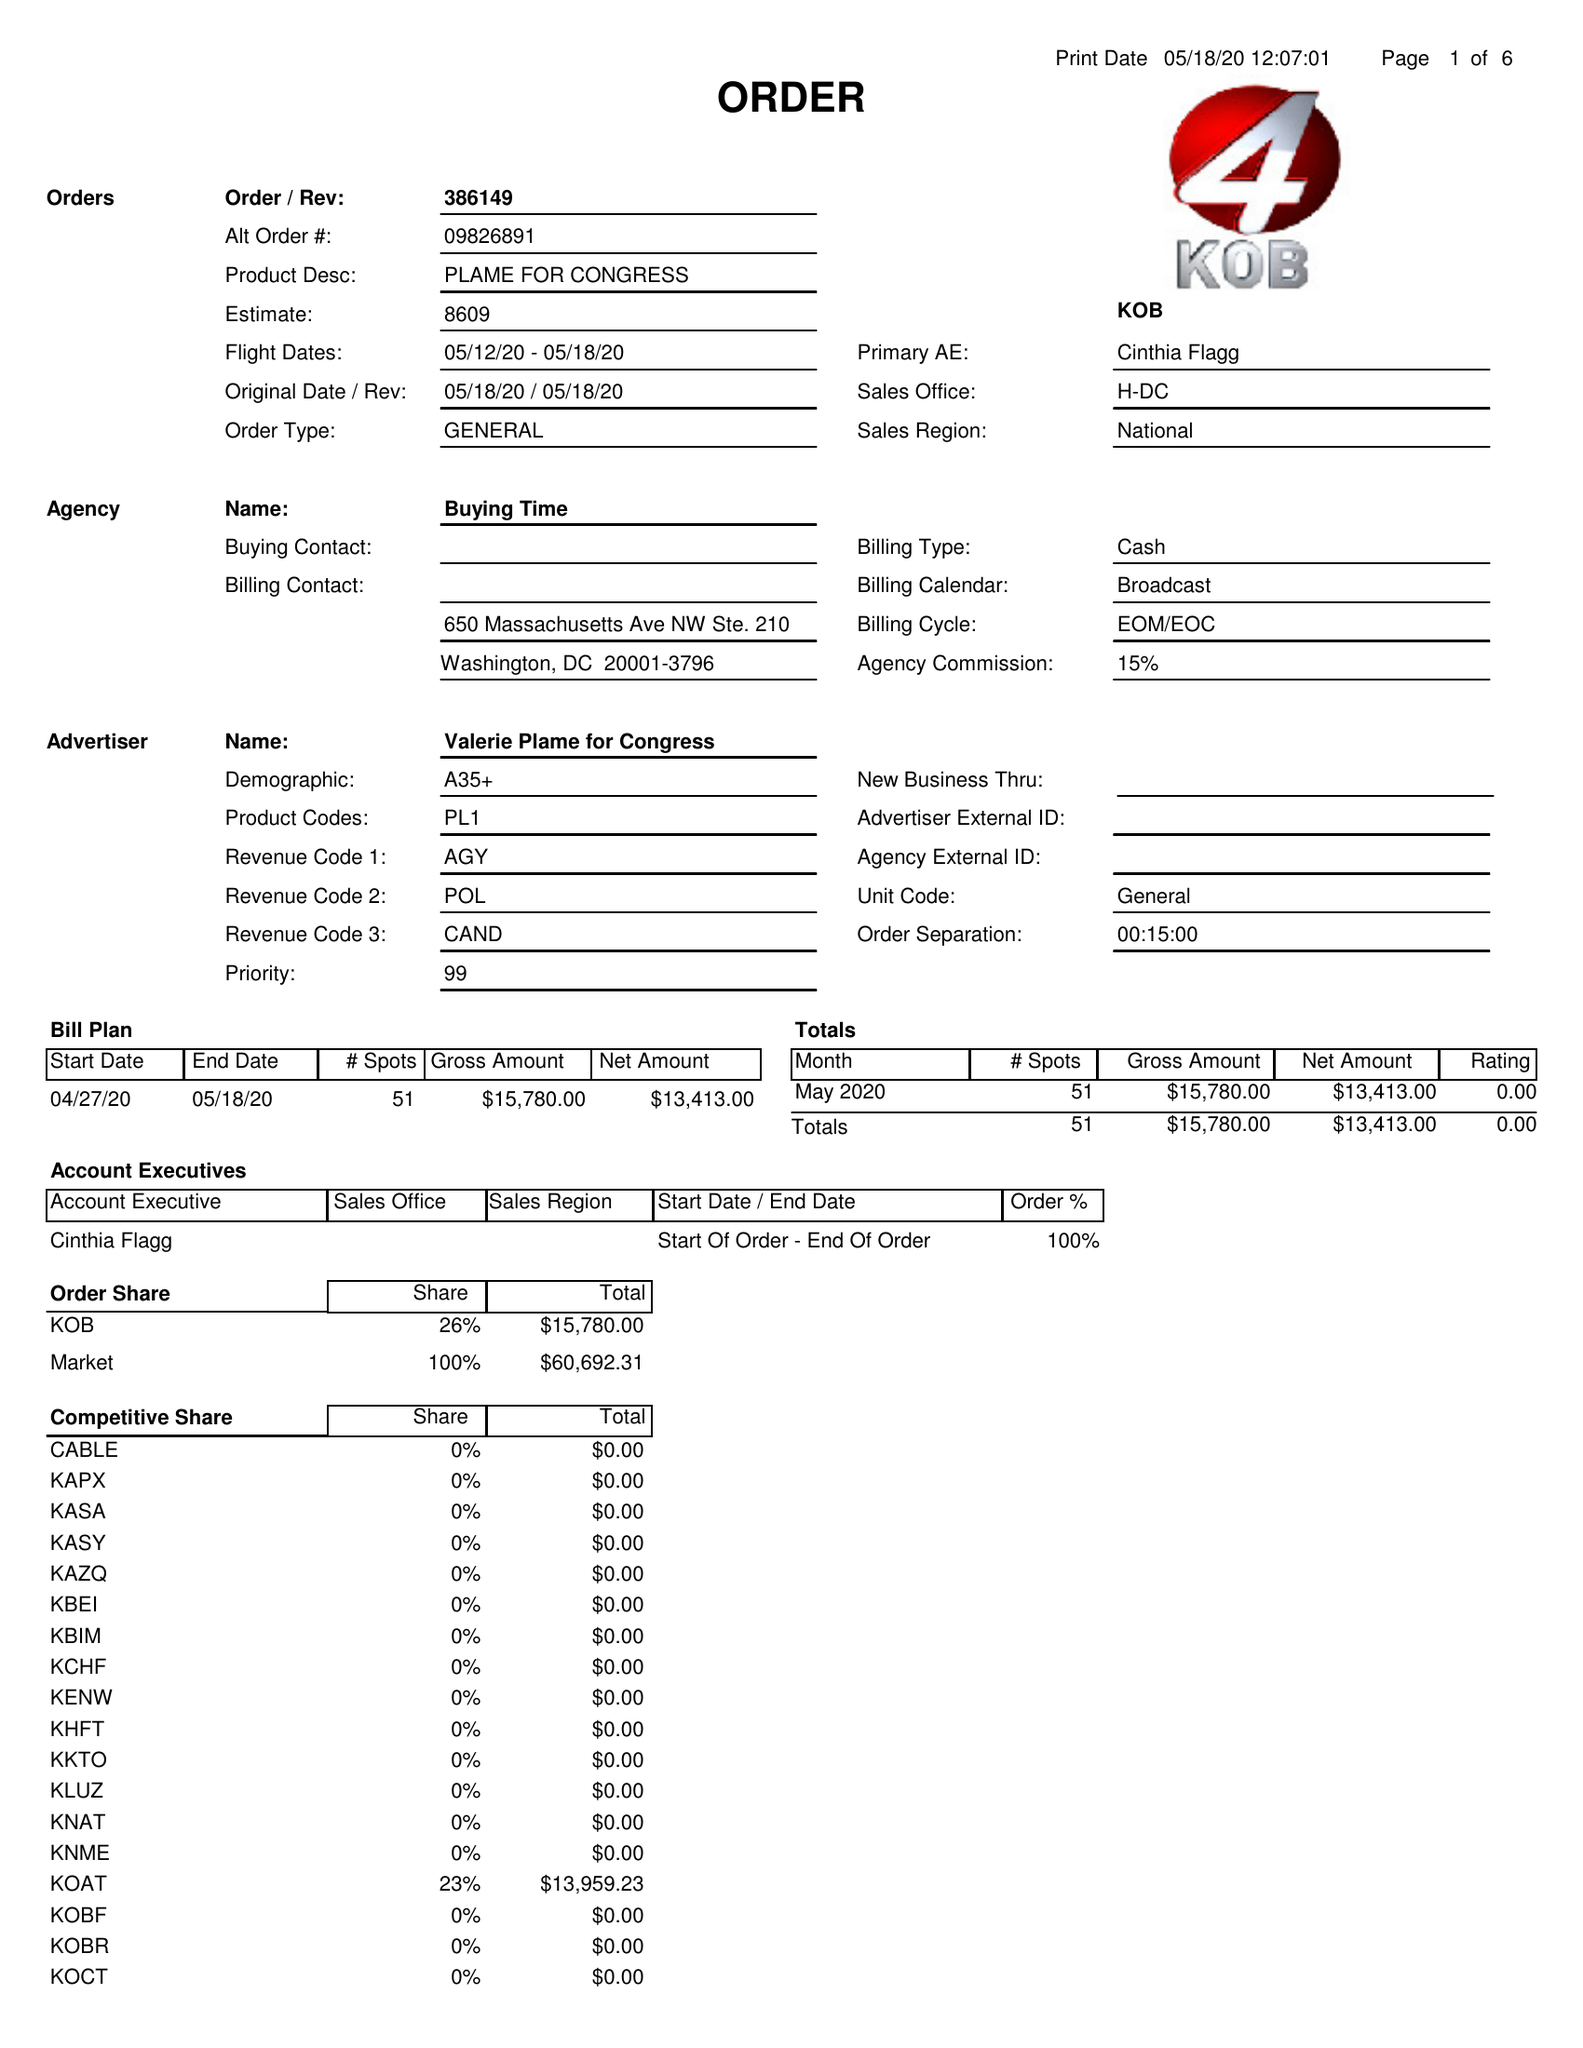What is the value for the contract_num?
Answer the question using a single word or phrase. 386149 